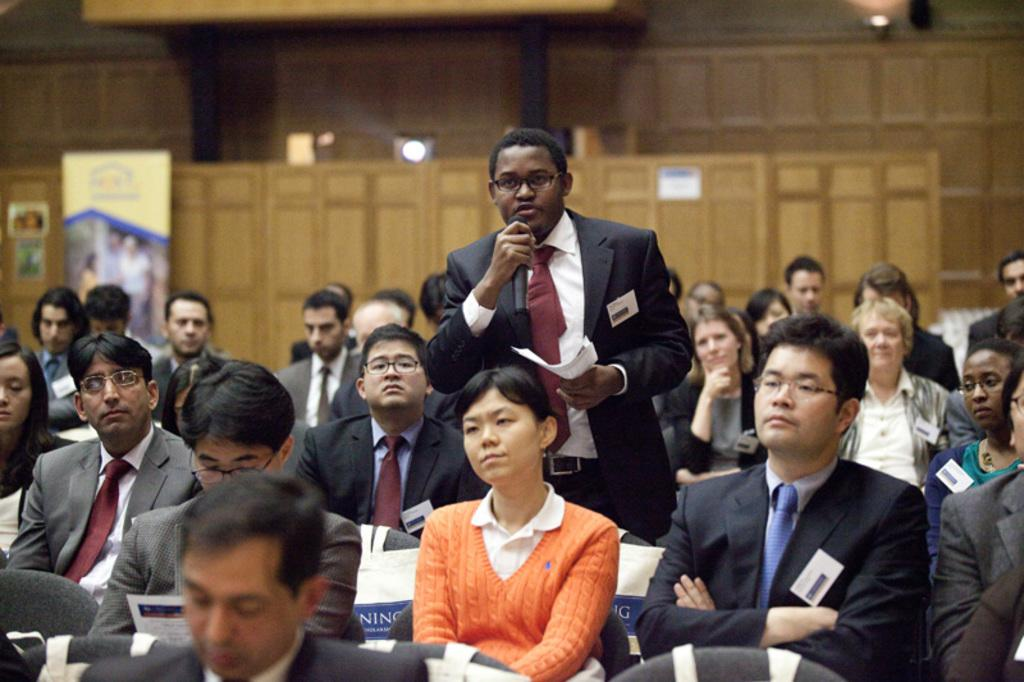What are the people in the image doing? The people in the image are sitting on chairs. What is the man in the image doing? The man is standing in the image and holding a microphone and a paper. What can be seen in the background of the image? There is a wall, a light, and a banner in the background of the image. What type of mint is being passed around during the protest in the image? There is no protest or mint present in the image. The man is holding a microphone and a paper, and there are people sitting on chairs. 